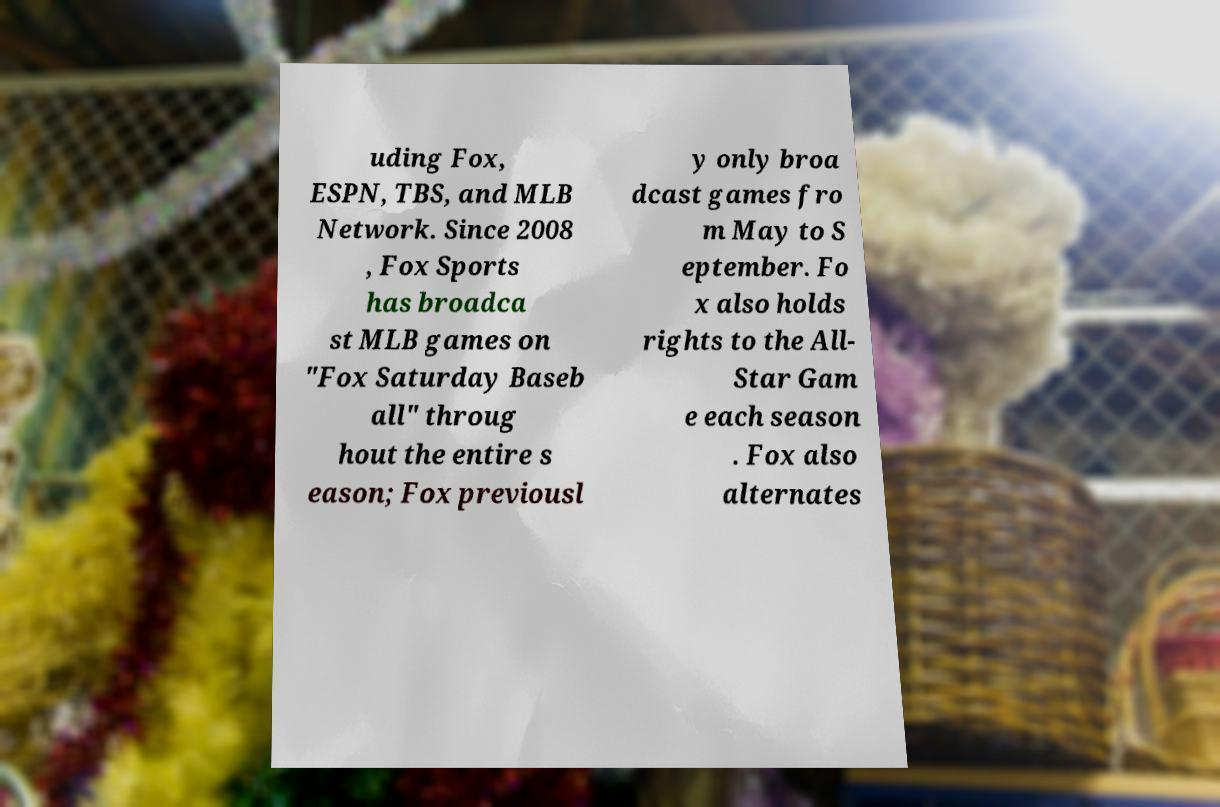Can you read and provide the text displayed in the image?This photo seems to have some interesting text. Can you extract and type it out for me? uding Fox, ESPN, TBS, and MLB Network. Since 2008 , Fox Sports has broadca st MLB games on "Fox Saturday Baseb all" throug hout the entire s eason; Fox previousl y only broa dcast games fro m May to S eptember. Fo x also holds rights to the All- Star Gam e each season . Fox also alternates 